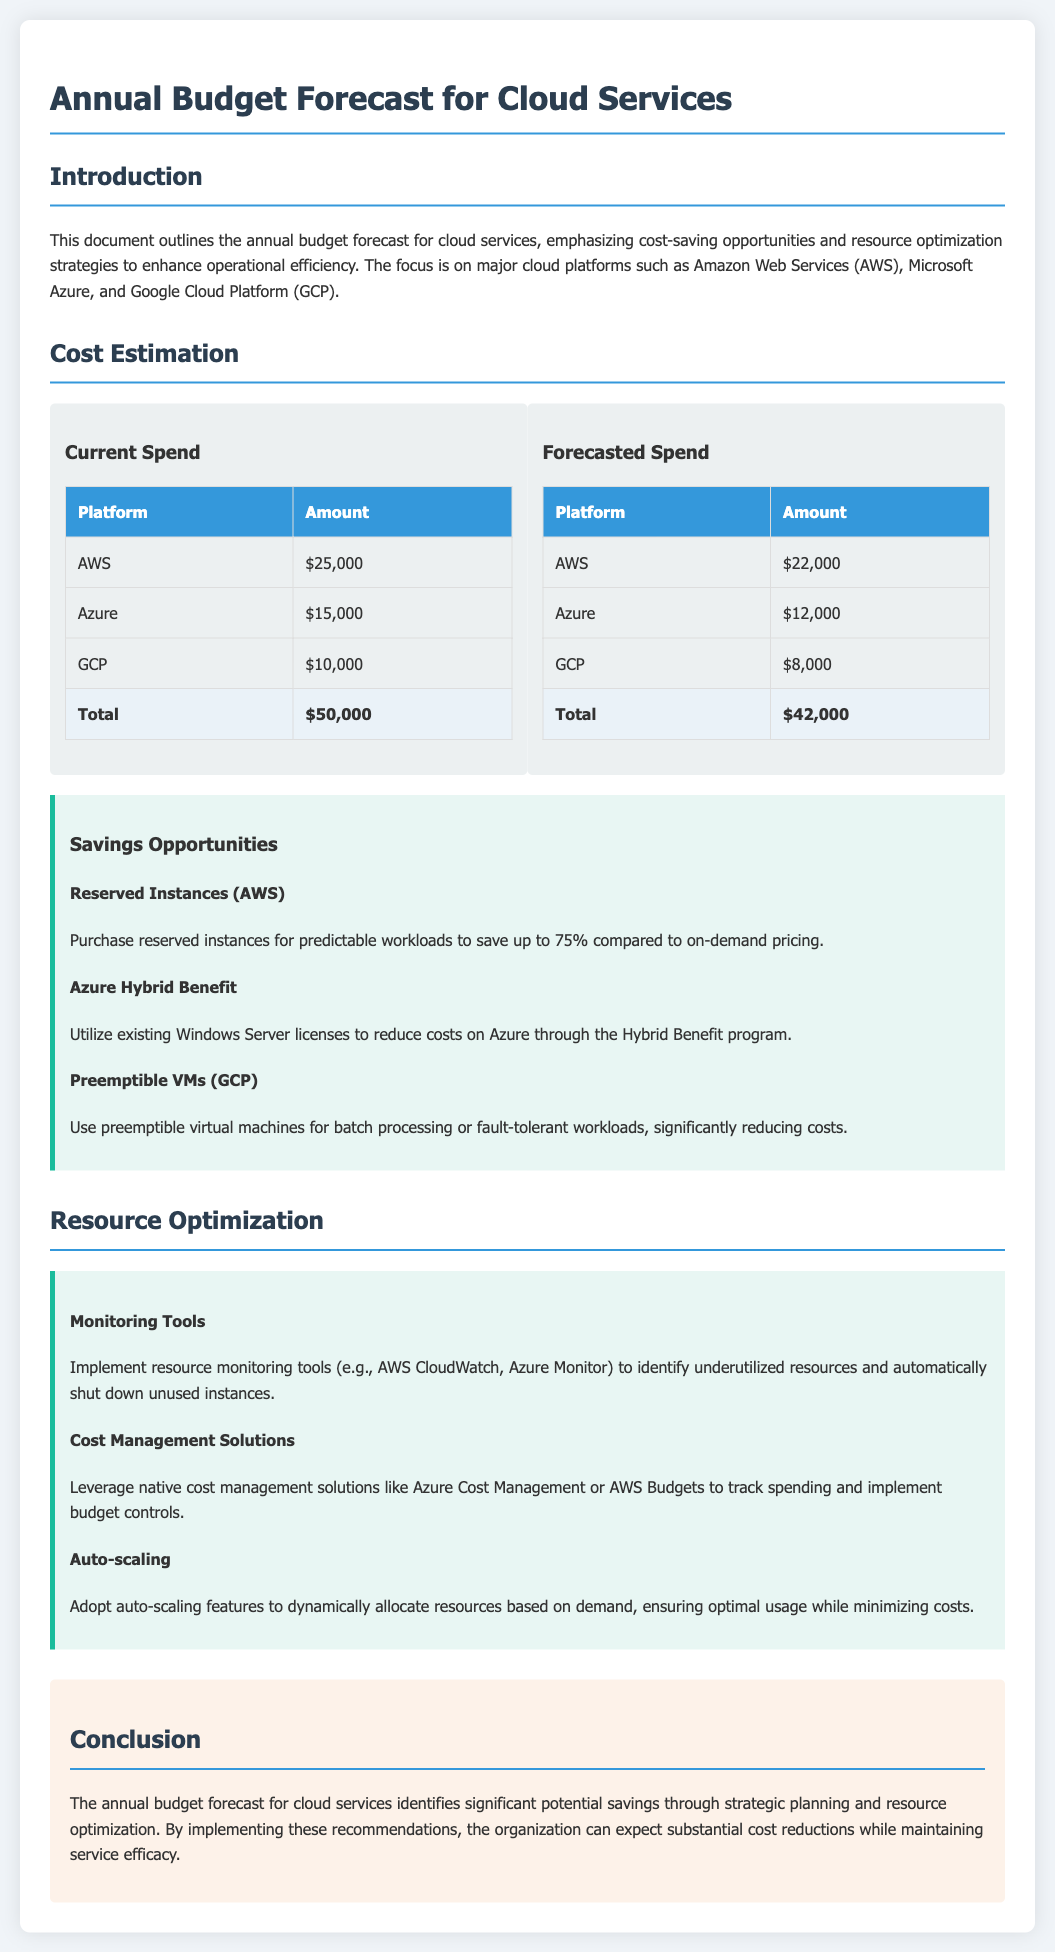What is the total current spend on cloud services? The document lists the current spend amounts for each platform, which sum up to $50,000.
Answer: $50,000 What is the forecasted spend for Google Cloud Platform? The document specifies that the forecasted spend for GCP is $8,000.
Answer: $8,000 What is one savings opportunity mentioned for AWS? The document describes purchasing reserved instances as a savings opportunity for AWS.
Answer: Reserved Instances What does Azure Hybrid Benefit help to reduce? The document indicates that the Azure Hybrid Benefit helps to reduce costs on Azure by utilizing existing Windows Server licenses.
Answer: Costs What is a recommendation for resource optimization mentioned? The document recommends implementing monitoring tools such as AWS CloudWatch and Azure Monitor for resource optimization.
Answer: Monitoring Tools What will the total forecasted spend be? The combined forecasted spend for all platforms according to the document totals $42,000.
Answer: $42,000 How much can cost be reduced by using reserved instances on AWS? The document states that reserved instances can save up to 75% compared to on-demand pricing.
Answer: 75% What is one feature to help minimize costs according to the resource optimization section? The document suggests adopting auto-scaling features to ensure optimal resource usage while minimizing costs.
Answer: Auto-scaling What does the conclusion indicate about potential savings? The conclusion states that there is significant potential savings through strategic planning and resource optimization.
Answer: Significant 